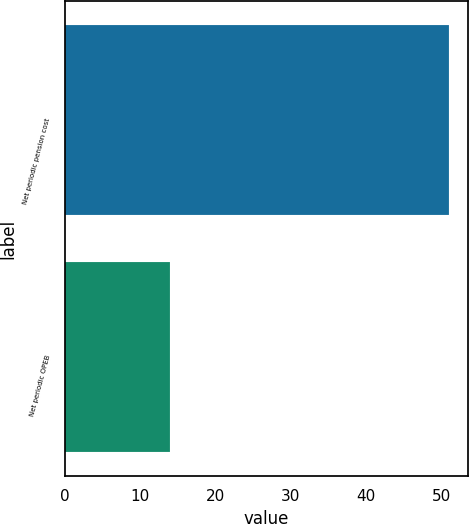Convert chart to OTSL. <chart><loc_0><loc_0><loc_500><loc_500><bar_chart><fcel>Net periodic pension cost<fcel>Net periodic OPEB<nl><fcel>51<fcel>14<nl></chart> 